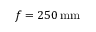<formula> <loc_0><loc_0><loc_500><loc_500>f = 2 5 0 \, m m</formula> 